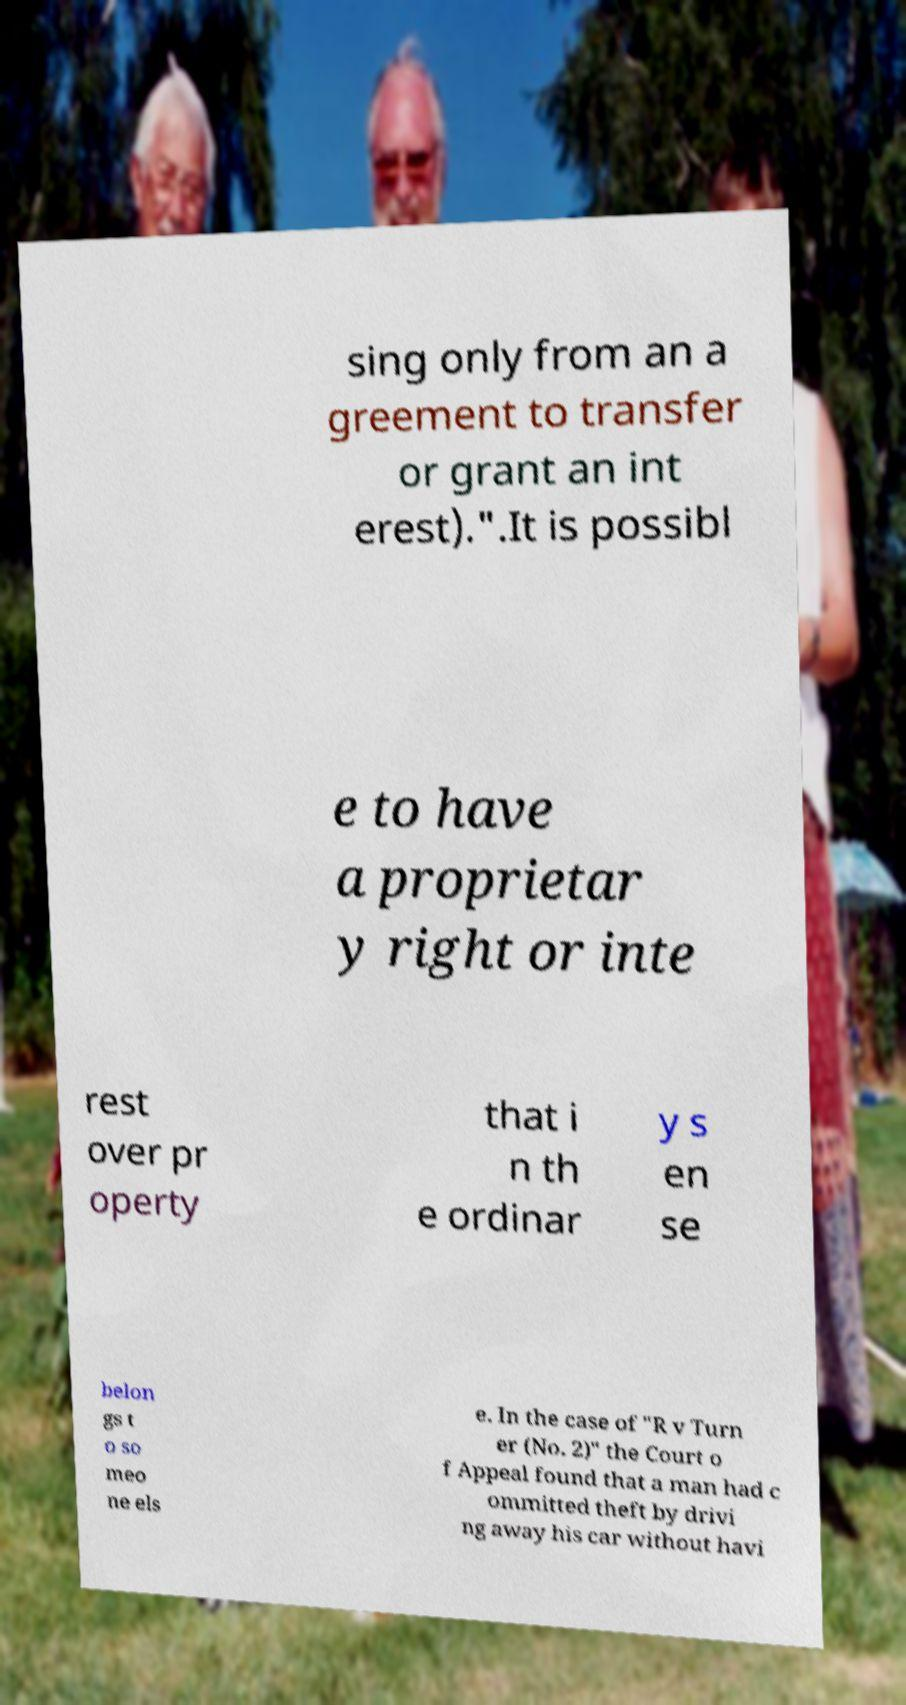Please read and relay the text visible in this image. What does it say? sing only from an a greement to transfer or grant an int erest).".It is possibl e to have a proprietar y right or inte rest over pr operty that i n th e ordinar y s en se belon gs t o so meo ne els e. In the case of "R v Turn er (No. 2)" the Court o f Appeal found that a man had c ommitted theft by drivi ng away his car without havi 